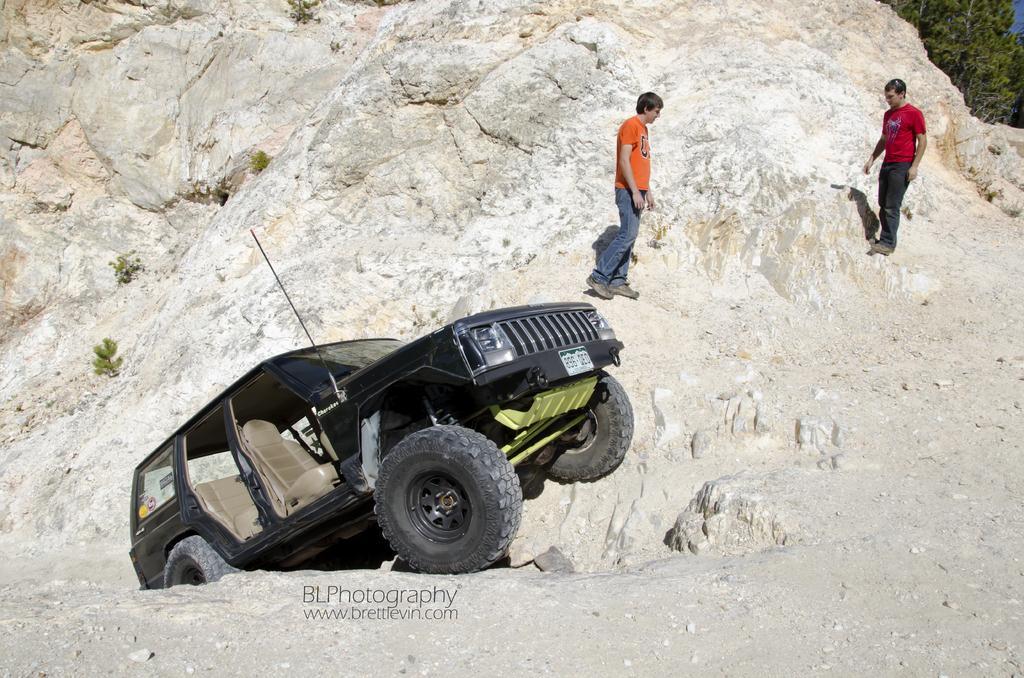Describe this image in one or two sentences. In this image we can see there is a car and there are two persons standing on the rock. 